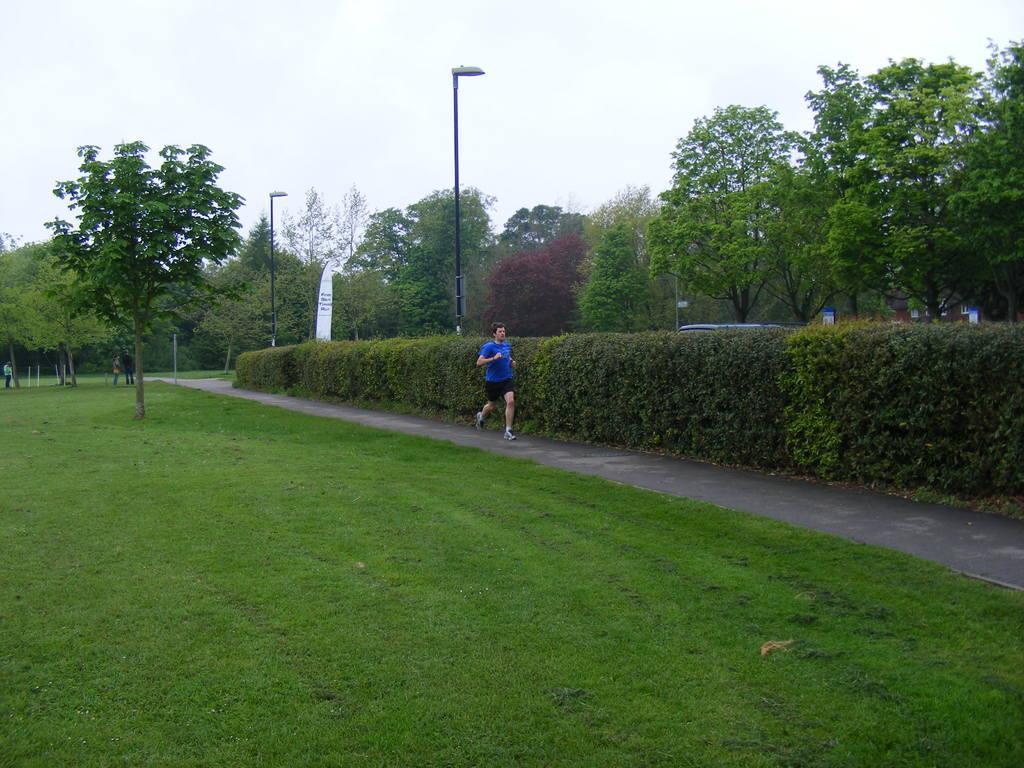Can you describe this image briefly? In this picture we can see a man is running on the path and behind the man there are plants, poles, trees and some people are standing on the path. Behind the trees there is a sky. 